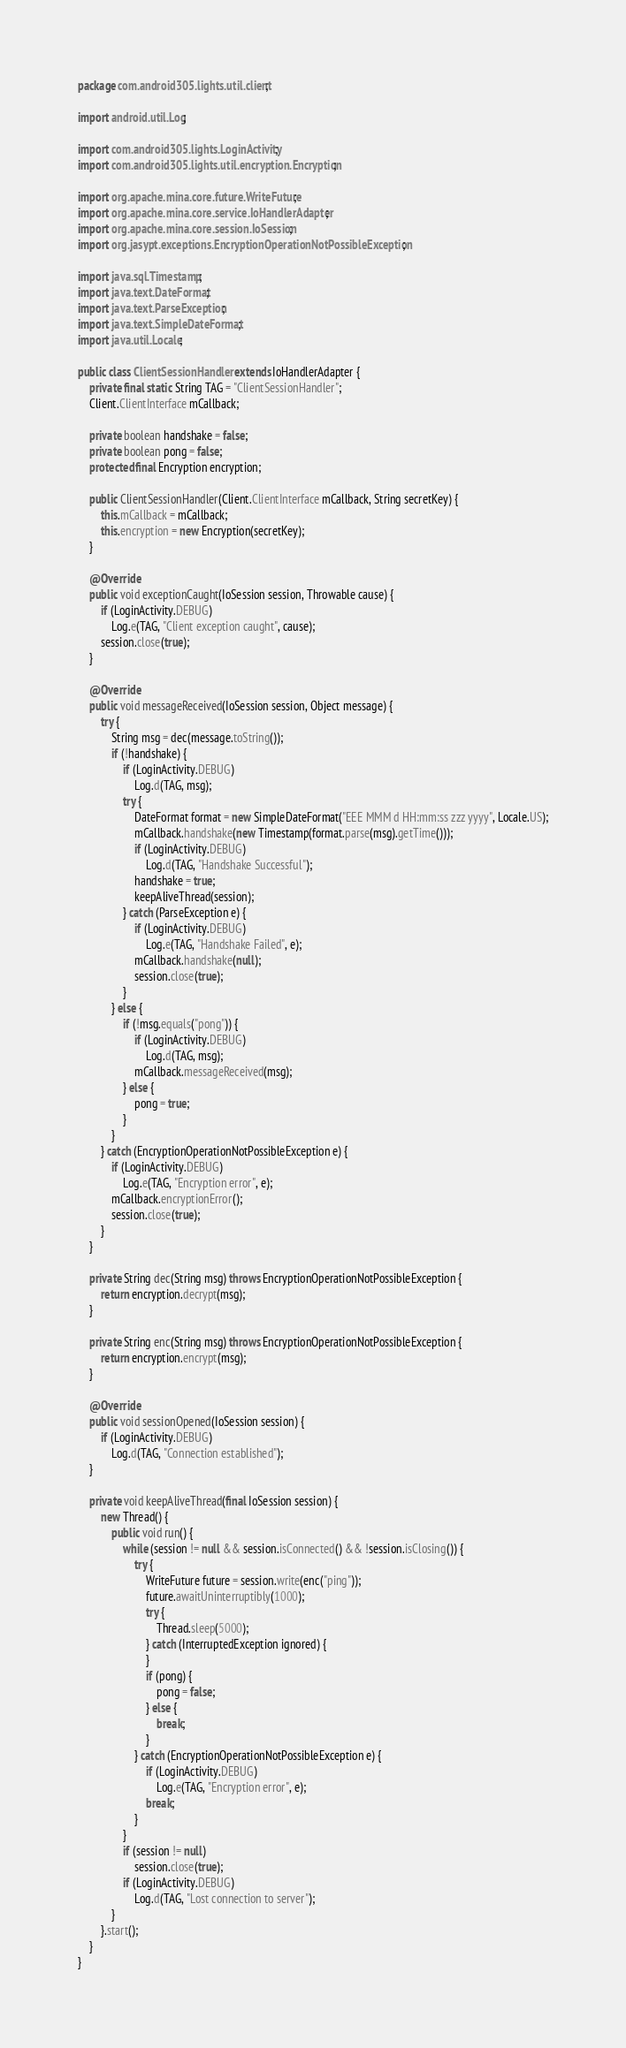Convert code to text. <code><loc_0><loc_0><loc_500><loc_500><_Java_>package com.android305.lights.util.client;

import android.util.Log;

import com.android305.lights.LoginActivity;
import com.android305.lights.util.encryption.Encryption;

import org.apache.mina.core.future.WriteFuture;
import org.apache.mina.core.service.IoHandlerAdapter;
import org.apache.mina.core.session.IoSession;
import org.jasypt.exceptions.EncryptionOperationNotPossibleException;

import java.sql.Timestamp;
import java.text.DateFormat;
import java.text.ParseException;
import java.text.SimpleDateFormat;
import java.util.Locale;

public class ClientSessionHandler extends IoHandlerAdapter {
    private final static String TAG = "ClientSessionHandler";
    Client.ClientInterface mCallback;

    private boolean handshake = false;
    private boolean pong = false;
    protected final Encryption encryption;

    public ClientSessionHandler(Client.ClientInterface mCallback, String secretKey) {
        this.mCallback = mCallback;
        this.encryption = new Encryption(secretKey);
    }

    @Override
    public void exceptionCaught(IoSession session, Throwable cause) {
        if (LoginActivity.DEBUG)
            Log.e(TAG, "Client exception caught", cause);
        session.close(true);
    }

    @Override
    public void messageReceived(IoSession session, Object message) {
        try {
            String msg = dec(message.toString());
            if (!handshake) {
                if (LoginActivity.DEBUG)
                    Log.d(TAG, msg);
                try {
                    DateFormat format = new SimpleDateFormat("EEE MMM d HH:mm:ss zzz yyyy", Locale.US);
                    mCallback.handshake(new Timestamp(format.parse(msg).getTime()));
                    if (LoginActivity.DEBUG)
                        Log.d(TAG, "Handshake Successful");
                    handshake = true;
                    keepAliveThread(session);
                } catch (ParseException e) {
                    if (LoginActivity.DEBUG)
                        Log.e(TAG, "Handshake Failed", e);
                    mCallback.handshake(null);
                    session.close(true);
                }
            } else {
                if (!msg.equals("pong")) {
                    if (LoginActivity.DEBUG)
                        Log.d(TAG, msg);
                    mCallback.messageReceived(msg);
                } else {
                    pong = true;
                }
            }
        } catch (EncryptionOperationNotPossibleException e) {
            if (LoginActivity.DEBUG)
                Log.e(TAG, "Encryption error", e);
            mCallback.encryptionError();
            session.close(true);
        }
    }

    private String dec(String msg) throws EncryptionOperationNotPossibleException {
        return encryption.decrypt(msg);
    }

    private String enc(String msg) throws EncryptionOperationNotPossibleException {
        return encryption.encrypt(msg);
    }

    @Override
    public void sessionOpened(IoSession session) {
        if (LoginActivity.DEBUG)
            Log.d(TAG, "Connection established");
    }

    private void keepAliveThread(final IoSession session) {
        new Thread() {
            public void run() {
                while (session != null && session.isConnected() && !session.isClosing()) {
                    try {
                        WriteFuture future = session.write(enc("ping"));
                        future.awaitUninterruptibly(1000);
                        try {
                            Thread.sleep(5000);
                        } catch (InterruptedException ignored) {
                        }
                        if (pong) {
                            pong = false;
                        } else {
                            break;
                        }
                    } catch (EncryptionOperationNotPossibleException e) {
                        if (LoginActivity.DEBUG)
                            Log.e(TAG, "Encryption error", e);
                        break;
                    }
                }
                if (session != null)
                    session.close(true);
                if (LoginActivity.DEBUG)
                    Log.d(TAG, "Lost connection to server");
            }
        }.start();
    }
}</code> 